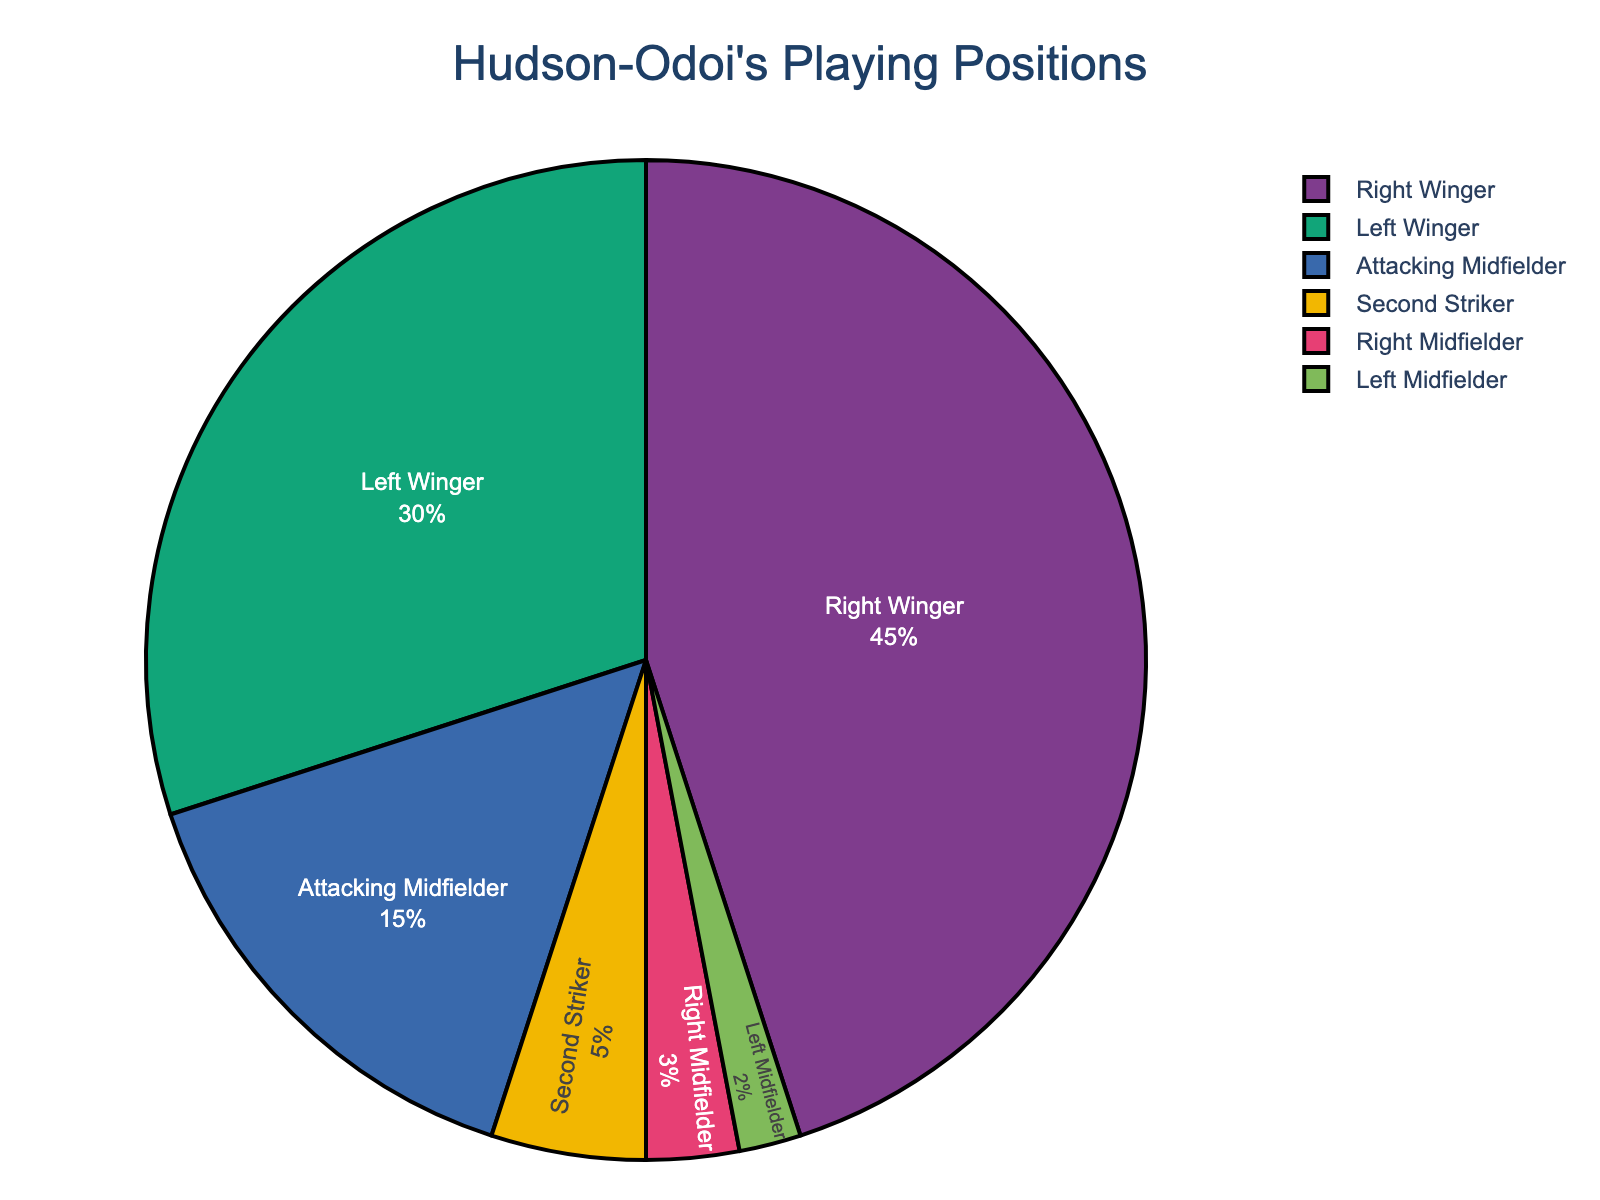what is the percentage of Hudson-Odoi's time playing as a Left Winger? To find the percentage of Hudson-Odoi’s time playing as a Left Winger, you need to look at the corresponding slice in the pie chart labeled "Left Winger".
Answer: 30% what is the combined percentage of Hudson-Odoi's time playing as a Right Winger and Right Midfielder? To calculate the combined percentage, add the percentages for "Right Winger" (45%) and "Right Midfielder" (3%). So, 45% + 3% = 48%.
Answer: 48% Which position has the smallest percentage of Hudson-Odoi's playing time? The position with the smallest percentage can be identified by looking at the slice of the pie chart with the smallest size or least percentage label. That is "Left Midfielder" at 2%.
Answer: Left Midfielder Is Hudson-Odoi more frequently playing as an Attacking Midfielder or a Second Striker? Compare the percentage of time he has spent as an Attacking Midfielder (15%) with that of a Second Striker (5%). Since 15% > 5%, he has spent more playing time as an Attacking Midfielder.
Answer: Attacking Midfielder What is the total percentage of time Hudson-Odoi has played in Midfielder positions? To calculate the total percentage, add the percentages for "Right Midfielder" (3%) and "Left Midfielder" (2%). So, 3% + 2% = 5%.
Answer: 5% How much more of Hudson-Odoi's playing time has been as a Right Winger compared to a Left Winger? Subtract the percentage for "Left Winger" (30%) from the percentage for "Right Winger" (45%). So, 45% - 30% = 15%.
Answer: 15% What is the most frequent position Hudson-Odoi has played throughout his career? The most frequent position is the one with the largest slice in the pie chart, which is "Right Winger" at 45%.
Answer: Right Winger If you combine the percentages of Left Midfielder and Second Striker, do they surpass the percentage of Attacking Midfielder? Add the percentages for "Left Midfielder" (2%) and "Second Striker" (5%) first to get 7%. Compare 7% with the percentage for "Attacking Midfielder" (15%). Since 7% < 15%, they do not surpass.
Answer: No How many positions have a percentage of playing time below 10%? Look at the pie chart and count the positions with percentages below 10%: "Second Striker" (5%), "Right Midfielder" (3%), and "Left Midfielder" (2%). There are 3 such positions.
Answer: 3 What fraction of Hudson-Odoi's playing time has been as either an Attacking Midfielder or Left Winger? Add the percentages for "Attacking Midfielder" (15%) and "Left Winger" (30%) to get the total percentage, which is 45%. Therefore, the fraction is 45/100 or simplified, 9/20.
Answer: 9/20 